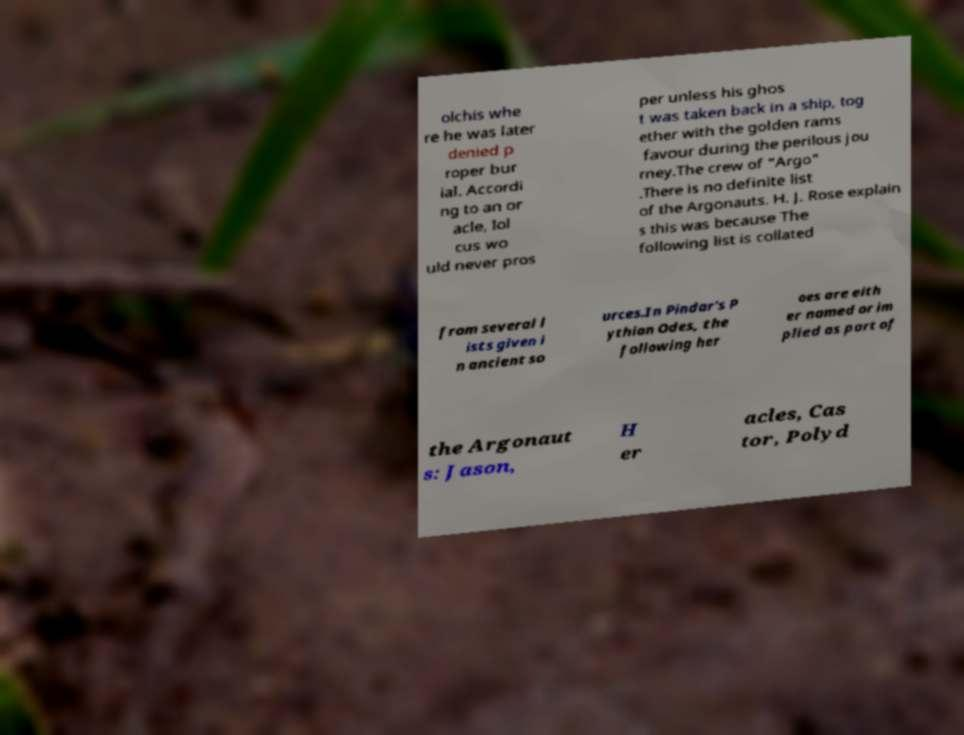Please read and relay the text visible in this image. What does it say? olchis whe re he was later denied p roper bur ial. Accordi ng to an or acle, Iol cus wo uld never pros per unless his ghos t was taken back in a ship, tog ether with the golden rams favour during the perilous jou rney.The crew of "Argo" .There is no definite list of the Argonauts. H. J. Rose explain s this was because The following list is collated from several l ists given i n ancient so urces.In Pindar's P ythian Odes, the following her oes are eith er named or im plied as part of the Argonaut s: Jason, H er acles, Cas tor, Polyd 